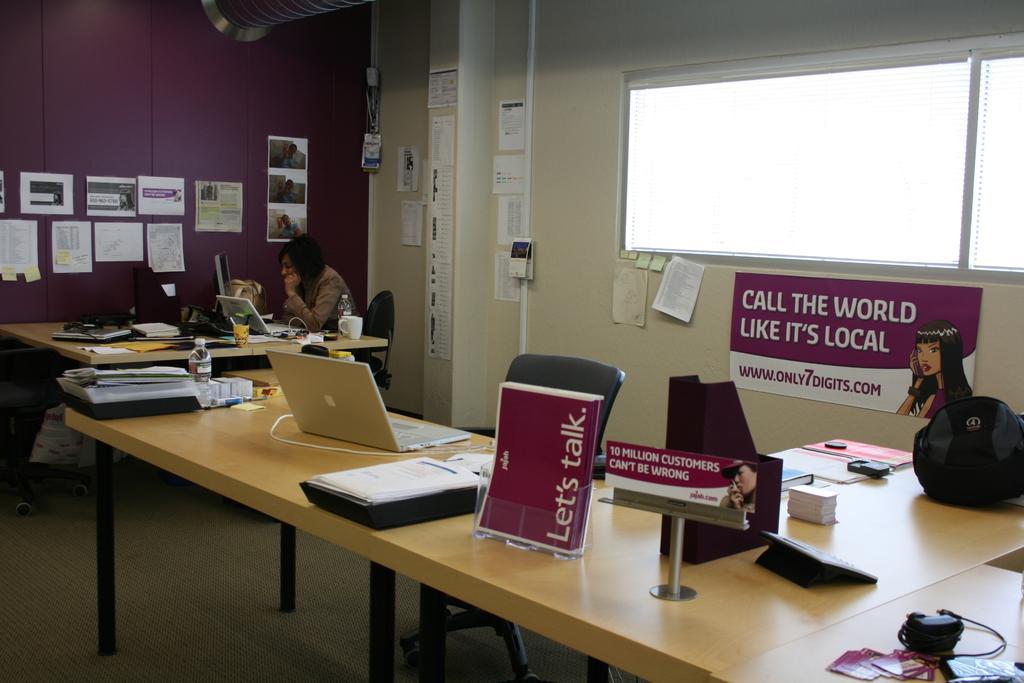How would you summarize this image in a sentence or two? Here we can see a table on the floor and some papers and some other objects and laptop and water bottle on it, and here a woman is sitting on the chair and working, and here is the wall and some papers on it. 